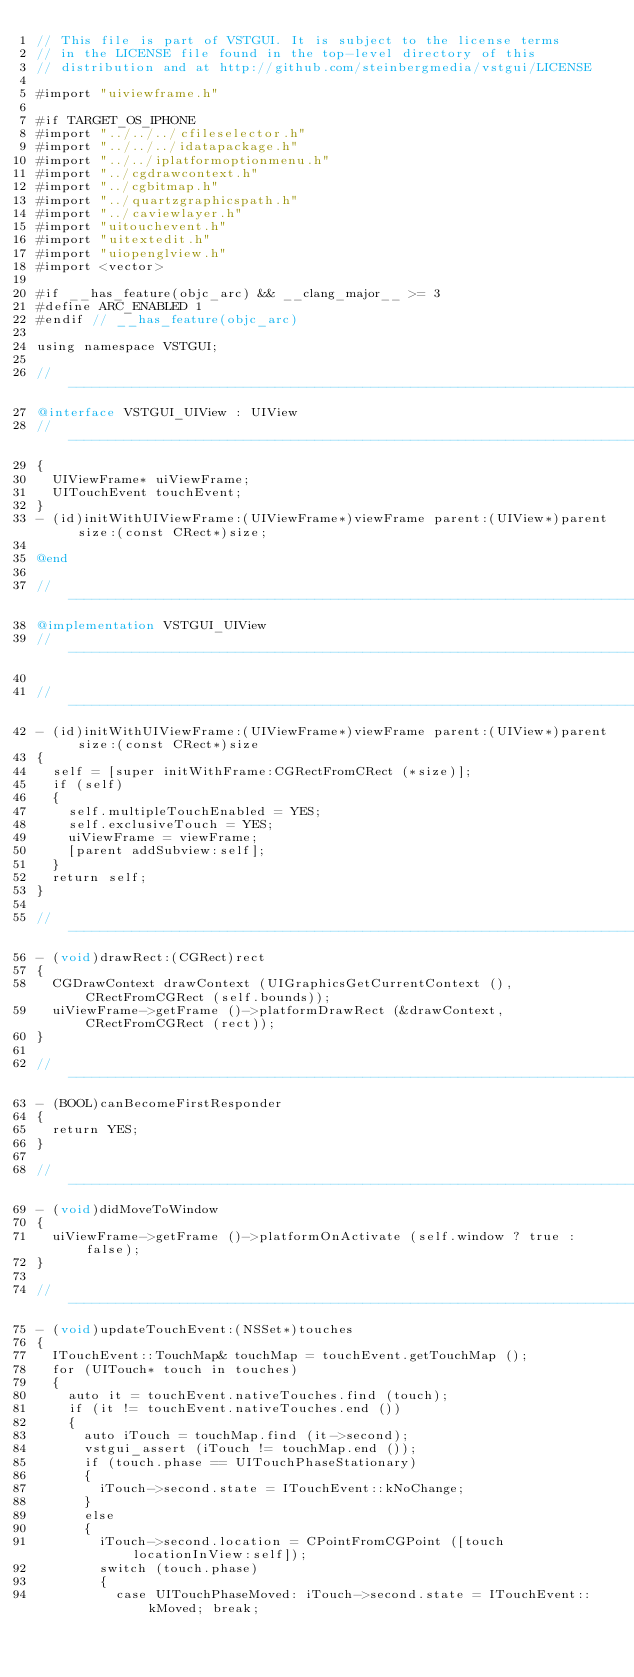Convert code to text. <code><loc_0><loc_0><loc_500><loc_500><_ObjectiveC_>// This file is part of VSTGUI. It is subject to the license terms 
// in the LICENSE file found in the top-level directory of this
// distribution and at http://github.com/steinbergmedia/vstgui/LICENSE

#import "uiviewframe.h"

#if TARGET_OS_IPHONE
#import "../../../cfileselector.h"
#import "../../../idatapackage.h"
#import "../../iplatformoptionmenu.h"
#import "../cgdrawcontext.h"
#import "../cgbitmap.h"
#import "../quartzgraphicspath.h"
#import "../caviewlayer.h"
#import "uitouchevent.h"
#import "uitextedit.h"
#import "uiopenglview.h"
#import <vector>

#if __has_feature(objc_arc) && __clang_major__ >= 3
#define ARC_ENABLED 1
#endif // __has_feature(objc_arc)

using namespace VSTGUI;

//-----------------------------------------------------------------------------
@interface VSTGUI_UIView : UIView
//-----------------------------------------------------------------------------
{
	UIViewFrame* uiViewFrame;
	UITouchEvent touchEvent;
}
- (id)initWithUIViewFrame:(UIViewFrame*)viewFrame parent:(UIView*)parent size:(const CRect*)size;

@end

//-----------------------------------------------------------------------------
@implementation VSTGUI_UIView
//-----------------------------------------------------------------------------

//-----------------------------------------------------------------------------
- (id)initWithUIViewFrame:(UIViewFrame*)viewFrame parent:(UIView*)parent size:(const CRect*)size
{
	self = [super initWithFrame:CGRectFromCRect (*size)];
	if (self)
	{
		self.multipleTouchEnabled = YES;
		self.exclusiveTouch = YES;
		uiViewFrame = viewFrame;
		[parent addSubview:self];
	}
	return self;
}

//-----------------------------------------------------------------------------
- (void)drawRect:(CGRect)rect
{
	CGDrawContext drawContext (UIGraphicsGetCurrentContext (), CRectFromCGRect (self.bounds));
	uiViewFrame->getFrame ()->platformDrawRect (&drawContext, CRectFromCGRect (rect));
}

//-----------------------------------------------------------------------------
- (BOOL)canBecomeFirstResponder
{
	return YES;
}

//-----------------------------------------------------------------------------
- (void)didMoveToWindow
{
	uiViewFrame->getFrame ()->platformOnActivate (self.window ? true : false);
}

//-----------------------------------------------------------------------------
- (void)updateTouchEvent:(NSSet*)touches
{
	ITouchEvent::TouchMap& touchMap = touchEvent.getTouchMap ();
	for (UITouch* touch in touches)
	{
		auto it = touchEvent.nativeTouches.find (touch);
		if (it != touchEvent.nativeTouches.end ())
		{
			auto iTouch = touchMap.find (it->second);
			vstgui_assert (iTouch != touchMap.end ());
			if (touch.phase == UITouchPhaseStationary)
			{
				iTouch->second.state = ITouchEvent::kNoChange;
			}
			else
			{
				iTouch->second.location = CPointFromCGPoint ([touch locationInView:self]);
				switch (touch.phase)
				{
					case UITouchPhaseMoved: iTouch->second.state = ITouchEvent::kMoved; break;</code> 